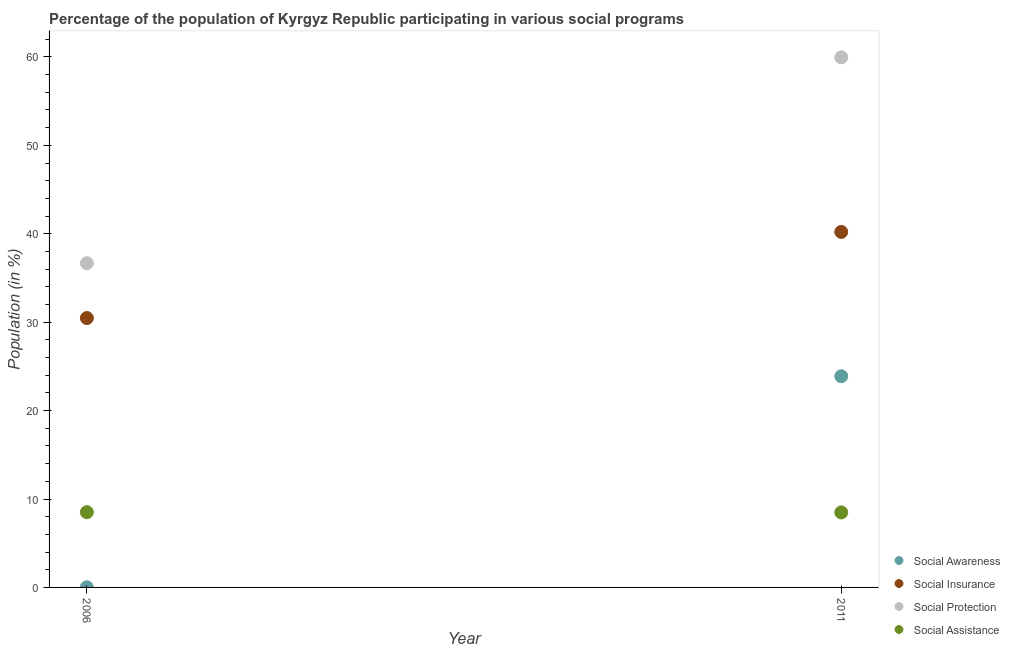Is the number of dotlines equal to the number of legend labels?
Offer a very short reply. Yes. What is the participation of population in social assistance programs in 2006?
Give a very brief answer. 8.51. Across all years, what is the maximum participation of population in social assistance programs?
Your answer should be very brief. 8.51. Across all years, what is the minimum participation of population in social awareness programs?
Ensure brevity in your answer.  0.02. In which year was the participation of population in social insurance programs maximum?
Ensure brevity in your answer.  2011. What is the total participation of population in social assistance programs in the graph?
Offer a terse response. 16.99. What is the difference between the participation of population in social awareness programs in 2006 and that in 2011?
Offer a terse response. -23.87. What is the difference between the participation of population in social assistance programs in 2011 and the participation of population in social awareness programs in 2006?
Your response must be concise. 8.47. What is the average participation of population in social protection programs per year?
Give a very brief answer. 48.31. In the year 2006, what is the difference between the participation of population in social awareness programs and participation of population in social assistance programs?
Ensure brevity in your answer.  -8.5. In how many years, is the participation of population in social protection programs greater than 32 %?
Your answer should be very brief. 2. What is the ratio of the participation of population in social assistance programs in 2006 to that in 2011?
Provide a short and direct response. 1. Is the participation of population in social assistance programs in 2006 less than that in 2011?
Offer a very short reply. No. In how many years, is the participation of population in social insurance programs greater than the average participation of population in social insurance programs taken over all years?
Offer a very short reply. 1. Is it the case that in every year, the sum of the participation of population in social protection programs and participation of population in social awareness programs is greater than the sum of participation of population in social assistance programs and participation of population in social insurance programs?
Offer a very short reply. Yes. Is it the case that in every year, the sum of the participation of population in social awareness programs and participation of population in social insurance programs is greater than the participation of population in social protection programs?
Your response must be concise. No. Does the participation of population in social assistance programs monotonically increase over the years?
Your answer should be compact. No. Is the participation of population in social awareness programs strictly greater than the participation of population in social protection programs over the years?
Ensure brevity in your answer.  No. What is the difference between two consecutive major ticks on the Y-axis?
Offer a very short reply. 10. Does the graph contain any zero values?
Keep it short and to the point. No. Where does the legend appear in the graph?
Provide a succinct answer. Bottom right. How many legend labels are there?
Your response must be concise. 4. What is the title of the graph?
Ensure brevity in your answer.  Percentage of the population of Kyrgyz Republic participating in various social programs . What is the label or title of the X-axis?
Your response must be concise. Year. What is the Population (in %) in Social Awareness in 2006?
Your answer should be very brief. 0.02. What is the Population (in %) of Social Insurance in 2006?
Ensure brevity in your answer.  30.47. What is the Population (in %) in Social Protection in 2006?
Your response must be concise. 36.66. What is the Population (in %) of Social Assistance in 2006?
Provide a succinct answer. 8.51. What is the Population (in %) of Social Awareness in 2011?
Offer a very short reply. 23.88. What is the Population (in %) in Social Insurance in 2011?
Your answer should be compact. 40.21. What is the Population (in %) of Social Protection in 2011?
Your answer should be compact. 59.95. What is the Population (in %) of Social Assistance in 2011?
Your response must be concise. 8.48. Across all years, what is the maximum Population (in %) in Social Awareness?
Give a very brief answer. 23.88. Across all years, what is the maximum Population (in %) in Social Insurance?
Your answer should be compact. 40.21. Across all years, what is the maximum Population (in %) in Social Protection?
Offer a very short reply. 59.95. Across all years, what is the maximum Population (in %) of Social Assistance?
Keep it short and to the point. 8.51. Across all years, what is the minimum Population (in %) of Social Awareness?
Offer a very short reply. 0.02. Across all years, what is the minimum Population (in %) of Social Insurance?
Provide a short and direct response. 30.47. Across all years, what is the minimum Population (in %) of Social Protection?
Offer a very short reply. 36.66. Across all years, what is the minimum Population (in %) of Social Assistance?
Provide a succinct answer. 8.48. What is the total Population (in %) of Social Awareness in the graph?
Keep it short and to the point. 23.9. What is the total Population (in %) of Social Insurance in the graph?
Keep it short and to the point. 70.67. What is the total Population (in %) in Social Protection in the graph?
Make the answer very short. 96.62. What is the total Population (in %) of Social Assistance in the graph?
Provide a short and direct response. 16.99. What is the difference between the Population (in %) of Social Awareness in 2006 and that in 2011?
Your answer should be compact. -23.87. What is the difference between the Population (in %) of Social Insurance in 2006 and that in 2011?
Give a very brief answer. -9.74. What is the difference between the Population (in %) in Social Protection in 2006 and that in 2011?
Provide a succinct answer. -23.29. What is the difference between the Population (in %) in Social Assistance in 2006 and that in 2011?
Your answer should be very brief. 0.03. What is the difference between the Population (in %) of Social Awareness in 2006 and the Population (in %) of Social Insurance in 2011?
Your answer should be very brief. -40.19. What is the difference between the Population (in %) in Social Awareness in 2006 and the Population (in %) in Social Protection in 2011?
Make the answer very short. -59.94. What is the difference between the Population (in %) in Social Awareness in 2006 and the Population (in %) in Social Assistance in 2011?
Keep it short and to the point. -8.47. What is the difference between the Population (in %) in Social Insurance in 2006 and the Population (in %) in Social Protection in 2011?
Your answer should be compact. -29.49. What is the difference between the Population (in %) of Social Insurance in 2006 and the Population (in %) of Social Assistance in 2011?
Your answer should be very brief. 21.98. What is the difference between the Population (in %) of Social Protection in 2006 and the Population (in %) of Social Assistance in 2011?
Ensure brevity in your answer.  28.18. What is the average Population (in %) of Social Awareness per year?
Ensure brevity in your answer.  11.95. What is the average Population (in %) of Social Insurance per year?
Offer a very short reply. 35.34. What is the average Population (in %) in Social Protection per year?
Offer a terse response. 48.31. What is the average Population (in %) of Social Assistance per year?
Offer a terse response. 8.5. In the year 2006, what is the difference between the Population (in %) in Social Awareness and Population (in %) in Social Insurance?
Offer a terse response. -30.45. In the year 2006, what is the difference between the Population (in %) in Social Awareness and Population (in %) in Social Protection?
Your answer should be very brief. -36.65. In the year 2006, what is the difference between the Population (in %) in Social Awareness and Population (in %) in Social Assistance?
Ensure brevity in your answer.  -8.5. In the year 2006, what is the difference between the Population (in %) of Social Insurance and Population (in %) of Social Protection?
Ensure brevity in your answer.  -6.2. In the year 2006, what is the difference between the Population (in %) in Social Insurance and Population (in %) in Social Assistance?
Your answer should be very brief. 21.96. In the year 2006, what is the difference between the Population (in %) in Social Protection and Population (in %) in Social Assistance?
Your response must be concise. 28.15. In the year 2011, what is the difference between the Population (in %) in Social Awareness and Population (in %) in Social Insurance?
Make the answer very short. -16.33. In the year 2011, what is the difference between the Population (in %) of Social Awareness and Population (in %) of Social Protection?
Make the answer very short. -36.07. In the year 2011, what is the difference between the Population (in %) of Social Awareness and Population (in %) of Social Assistance?
Offer a terse response. 15.4. In the year 2011, what is the difference between the Population (in %) in Social Insurance and Population (in %) in Social Protection?
Provide a succinct answer. -19.75. In the year 2011, what is the difference between the Population (in %) in Social Insurance and Population (in %) in Social Assistance?
Your answer should be very brief. 31.73. In the year 2011, what is the difference between the Population (in %) of Social Protection and Population (in %) of Social Assistance?
Make the answer very short. 51.47. What is the ratio of the Population (in %) of Social Awareness in 2006 to that in 2011?
Your answer should be very brief. 0. What is the ratio of the Population (in %) in Social Insurance in 2006 to that in 2011?
Make the answer very short. 0.76. What is the ratio of the Population (in %) in Social Protection in 2006 to that in 2011?
Make the answer very short. 0.61. What is the ratio of the Population (in %) of Social Assistance in 2006 to that in 2011?
Provide a succinct answer. 1. What is the difference between the highest and the second highest Population (in %) of Social Awareness?
Keep it short and to the point. 23.87. What is the difference between the highest and the second highest Population (in %) of Social Insurance?
Your answer should be very brief. 9.74. What is the difference between the highest and the second highest Population (in %) of Social Protection?
Provide a succinct answer. 23.29. What is the difference between the highest and the second highest Population (in %) of Social Assistance?
Provide a short and direct response. 0.03. What is the difference between the highest and the lowest Population (in %) in Social Awareness?
Your response must be concise. 23.87. What is the difference between the highest and the lowest Population (in %) of Social Insurance?
Provide a succinct answer. 9.74. What is the difference between the highest and the lowest Population (in %) in Social Protection?
Your answer should be very brief. 23.29. What is the difference between the highest and the lowest Population (in %) in Social Assistance?
Ensure brevity in your answer.  0.03. 